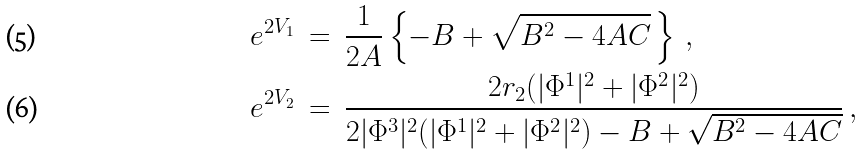Convert formula to latex. <formula><loc_0><loc_0><loc_500><loc_500>\ e ^ { 2 V _ { 1 } } \ & = \ \frac { 1 } { 2 A } \left \{ - B + \sqrt { B ^ { 2 } - 4 A C } \, \right \} \, , \\ \ e ^ { 2 V _ { 2 } } \ & = \ \frac { 2 r _ { 2 } ( | \Phi ^ { 1 } | ^ { 2 } + | \Phi ^ { 2 } | ^ { 2 } ) } { 2 | \Phi ^ { 3 } | ^ { 2 } ( | \Phi ^ { 1 } | ^ { 2 } + | \Phi ^ { 2 } | ^ { 2 } ) - B + \sqrt { B ^ { 2 } - 4 A C } } \, ,</formula> 